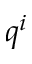Convert formula to latex. <formula><loc_0><loc_0><loc_500><loc_500>q ^ { i }</formula> 